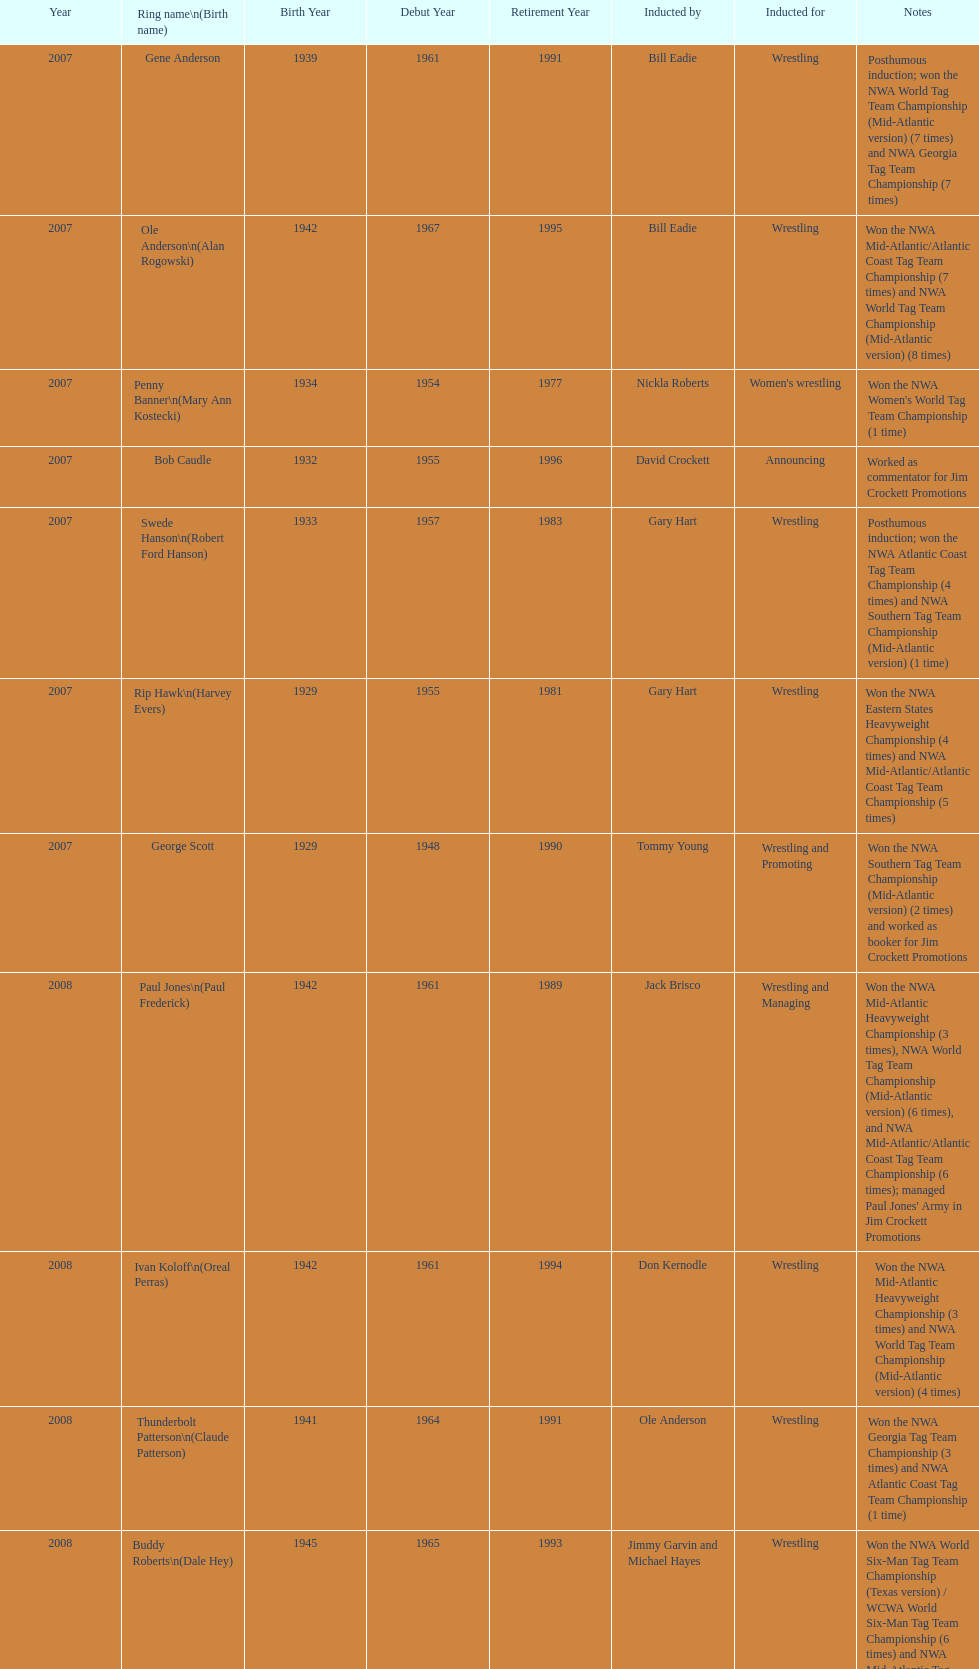Tell me an inductee that was not living at the time. Gene Anderson. 